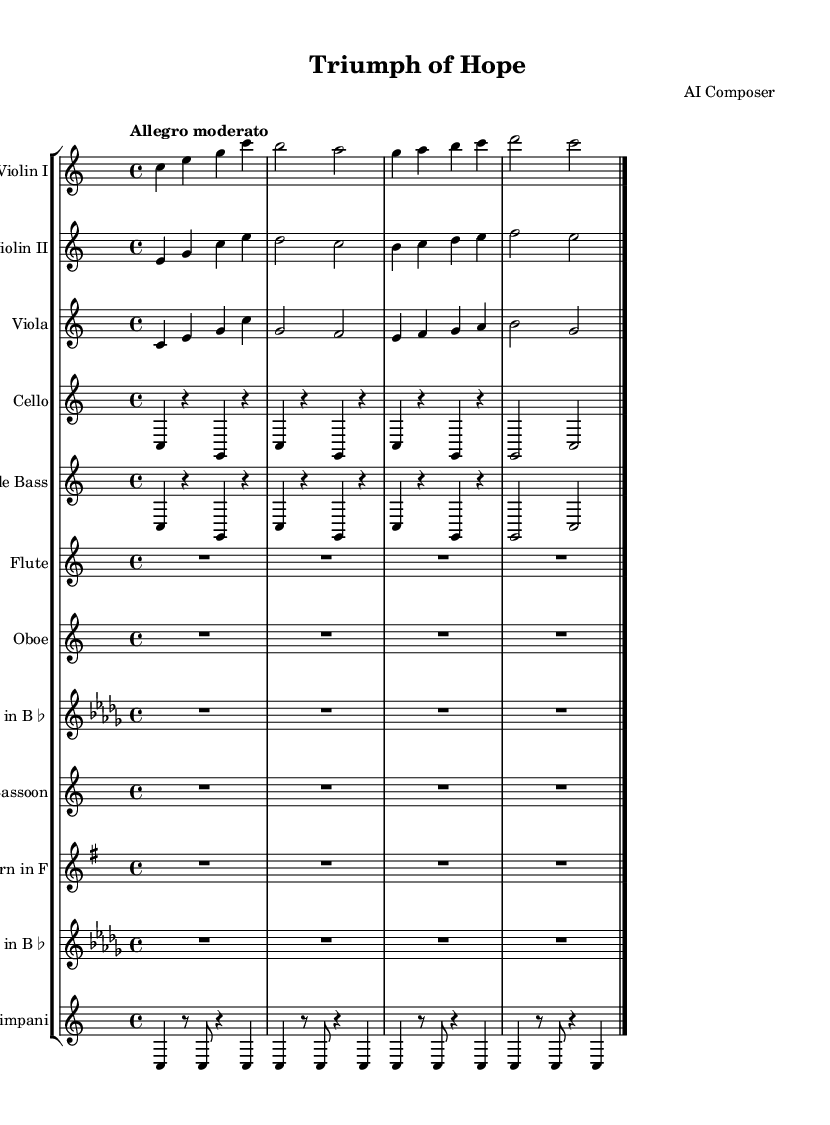What is the key signature of this music? The key signature is indicated at the beginning of the score, and it shows no sharps or flats, which corresponds to C major.
Answer: C major What is the time signature of this music? The time signature is shown at the beginning of the score, represented as 4/4, indicating four beats per measure.
Answer: 4/4 What is the tempo marking of this music? The tempo marking is typically written above the staff, and in this score, it states "Allegro moderato," suggesting a moderately fast pace.
Answer: Allegro moderato How many instrumental parts are included in this composition? By counting the number of separate staves, we see there are 12 distinct instrumental parts listed in the score.
Answer: 12 What is the highest pitch instrument in this composition? The highest pitch instrument among those listed is the Flute, which typically plays higher than the rest of the orchestral instruments.
Answer: Flute What common musical technique is used in the strings to enhance the uplifting nature of the piece? The score shows sustained notes and patterns that are typical for string instruments in uplifting symphonic music, providing a sense of warmth and harmony.
Answer: Sustained notes What ensemble type does this piece belong to? By observing the variety of instruments present, including strings, woodwinds, brass, and percussion, we can determine it is an orchestral ensemble.
Answer: Orchestra 